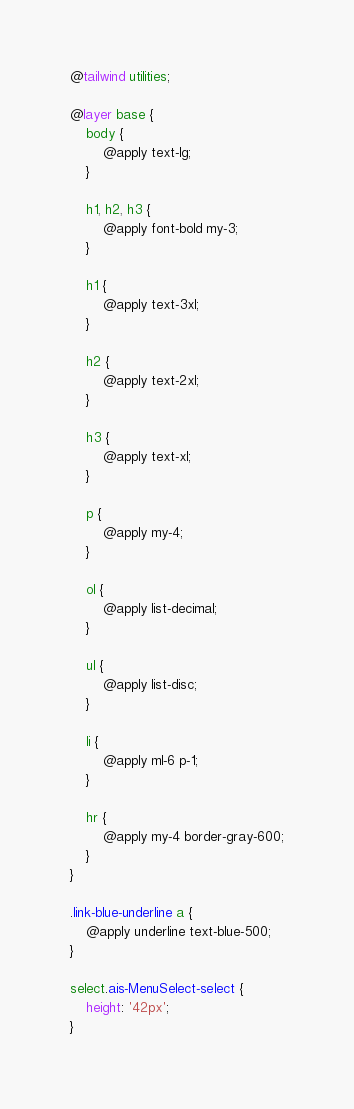Convert code to text. <code><loc_0><loc_0><loc_500><loc_500><_CSS_>@tailwind utilities;

@layer base {
    body {
        @apply text-lg;
    }

    h1, h2, h3 {
        @apply font-bold my-3;
    }

    h1 {
        @apply text-3xl;
    }

    h2 {
        @apply text-2xl;
    }

    h3 {
        @apply text-xl;
    }

    p {
        @apply my-4;
    }

    ol {
        @apply list-decimal;
    }

    ul {
        @apply list-disc;
    }

    li {
        @apply ml-6 p-1;
    }

    hr {
        @apply my-4 border-gray-600;
    }
}

.link-blue-underline a {
    @apply underline text-blue-500;
}

select.ais-MenuSelect-select {
    height: '42px';
}
</code> 